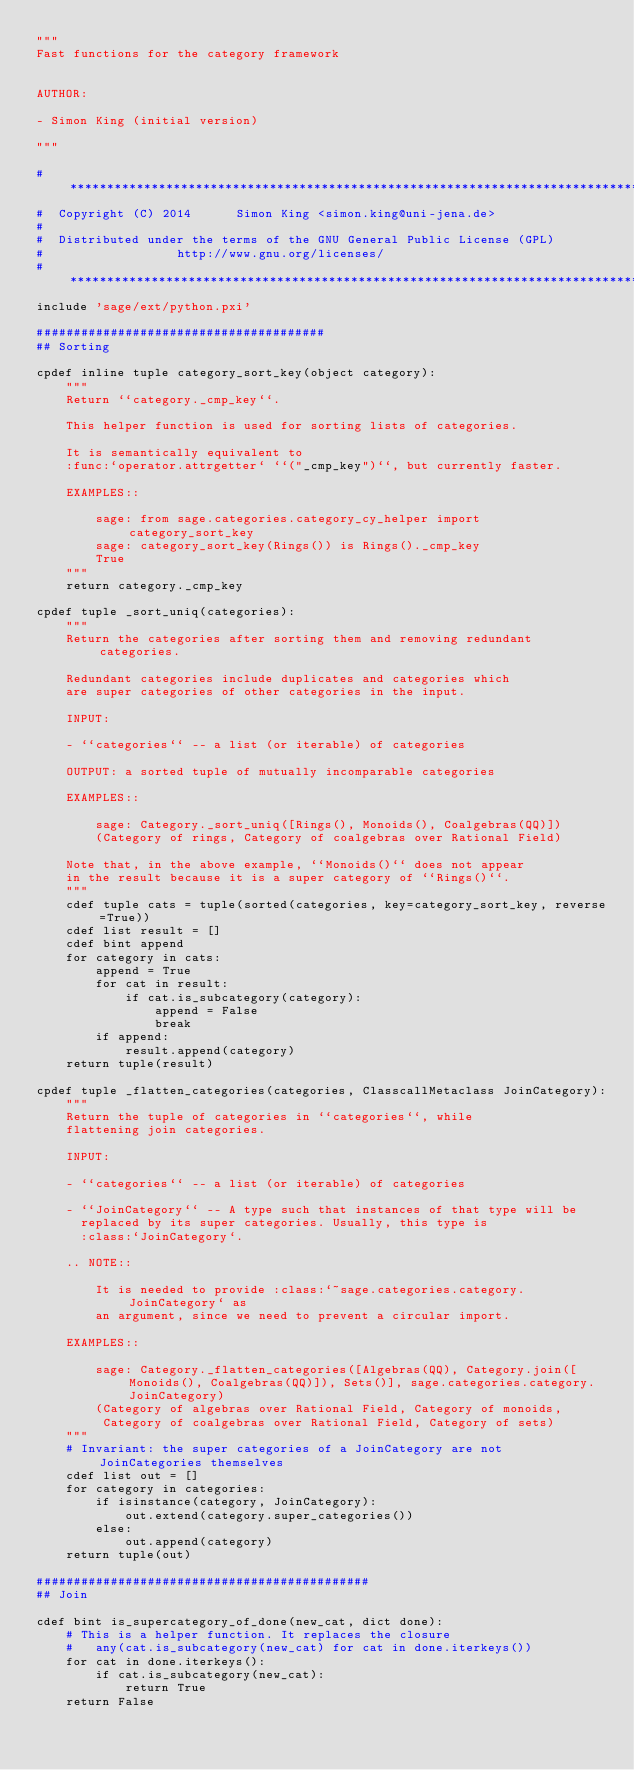<code> <loc_0><loc_0><loc_500><loc_500><_Cython_>"""
Fast functions for the category framework


AUTHOR:

- Simon King (initial version)

"""

#*****************************************************************************
#  Copyright (C) 2014      Simon King <simon.king@uni-jena.de>
#
#  Distributed under the terms of the GNU General Public License (GPL)
#                  http://www.gnu.org/licenses/
#*****************************************************************************
include 'sage/ext/python.pxi'

#######################################
## Sorting

cpdef inline tuple category_sort_key(object category):
    """
    Return ``category._cmp_key``.

    This helper function is used for sorting lists of categories.

    It is semantically equivalent to
    :func:`operator.attrgetter` ``("_cmp_key")``, but currently faster.

    EXAMPLES::

        sage: from sage.categories.category_cy_helper import category_sort_key
        sage: category_sort_key(Rings()) is Rings()._cmp_key
        True
    """
    return category._cmp_key

cpdef tuple _sort_uniq(categories):
    """
    Return the categories after sorting them and removing redundant categories.

    Redundant categories include duplicates and categories which
    are super categories of other categories in the input.

    INPUT:

    - ``categories`` -- a list (or iterable) of categories

    OUTPUT: a sorted tuple of mutually incomparable categories

    EXAMPLES::

        sage: Category._sort_uniq([Rings(), Monoids(), Coalgebras(QQ)])
        (Category of rings, Category of coalgebras over Rational Field)

    Note that, in the above example, ``Monoids()`` does not appear
    in the result because it is a super category of ``Rings()``.
    """
    cdef tuple cats = tuple(sorted(categories, key=category_sort_key, reverse=True))
    cdef list result = []
    cdef bint append
    for category in cats:
        append = True
        for cat in result:
            if cat.is_subcategory(category):
                append = False
                break
        if append:
            result.append(category)
    return tuple(result)

cpdef tuple _flatten_categories(categories, ClasscallMetaclass JoinCategory):
    """
    Return the tuple of categories in ``categories``, while
    flattening join categories.

    INPUT:

    - ``categories`` -- a list (or iterable) of categories

    - ``JoinCategory`` -- A type such that instances of that type will be
      replaced by its super categories. Usually, this type is
      :class:`JoinCategory`.

    .. NOTE::

        It is needed to provide :class:`~sage.categories.category.JoinCategory` as
        an argument, since we need to prevent a circular import.

    EXAMPLES::

        sage: Category._flatten_categories([Algebras(QQ), Category.join([Monoids(), Coalgebras(QQ)]), Sets()], sage.categories.category.JoinCategory)
        (Category of algebras over Rational Field, Category of monoids,
         Category of coalgebras over Rational Field, Category of sets)
    """
    # Invariant: the super categories of a JoinCategory are not JoinCategories themselves
    cdef list out = []
    for category in categories:
        if isinstance(category, JoinCategory):
            out.extend(category.super_categories())
        else:
            out.append(category)
    return tuple(out)

#############################################
## Join

cdef bint is_supercategory_of_done(new_cat, dict done):
    # This is a helper function. It replaces the closure
    #   any(cat.is_subcategory(new_cat) for cat in done.iterkeys())
    for cat in done.iterkeys():
        if cat.is_subcategory(new_cat):
            return True
    return False
</code> 